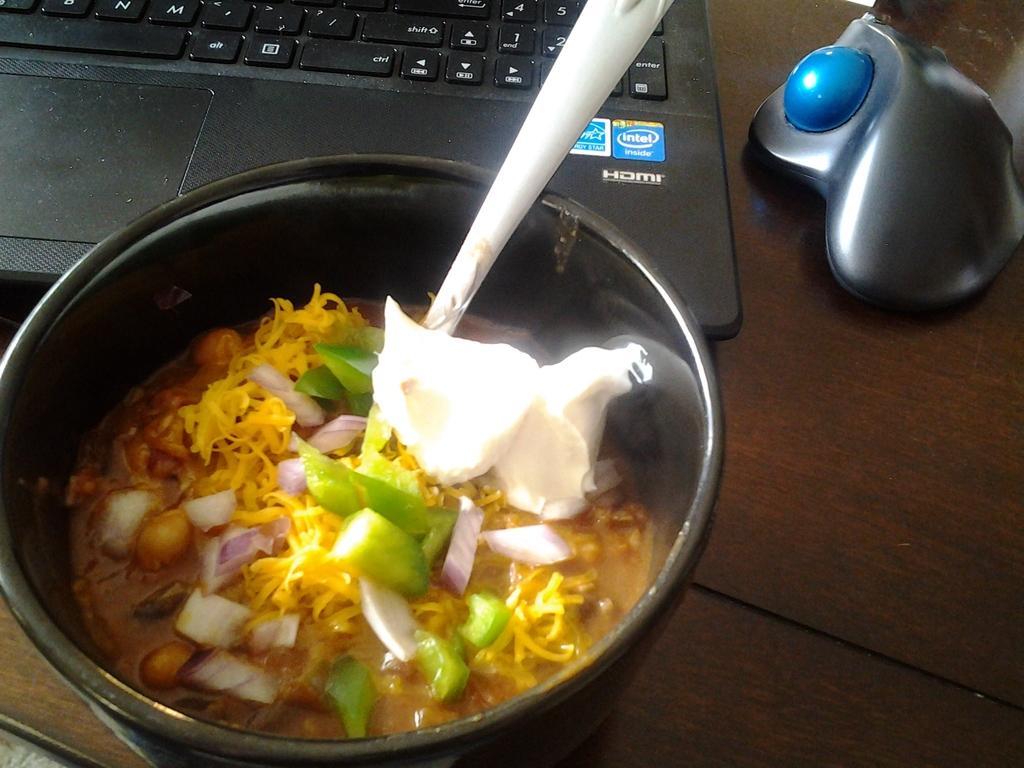Describe this image in one or two sentences. In this image, we can see some food item and a spoon in a container. We can see a laptop and a mouse on the wooden surface. 